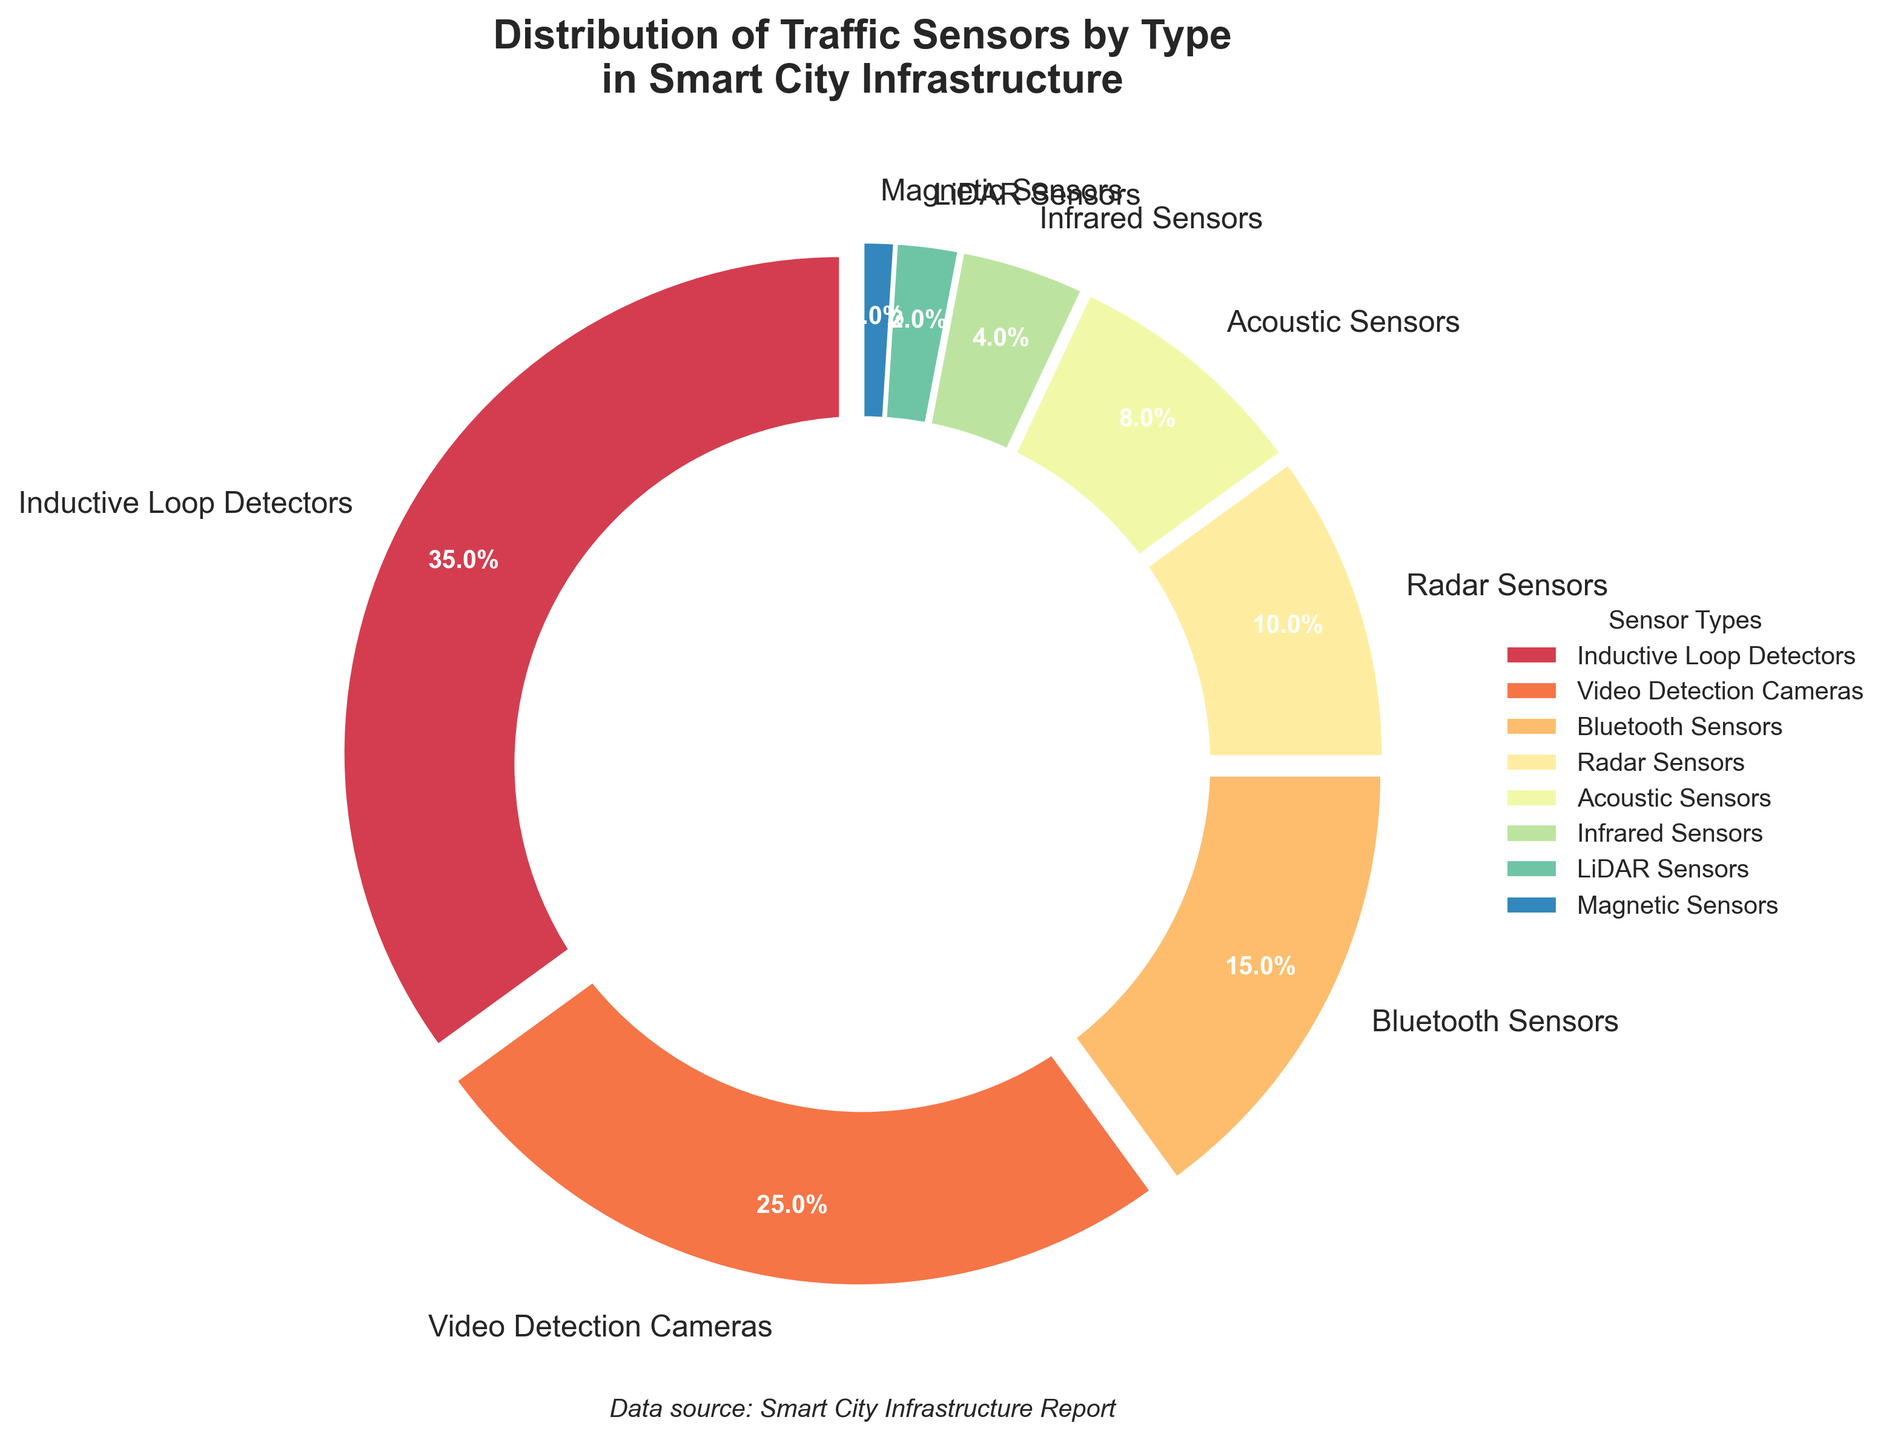What percentage of traffic sensors are Inductive Loop Detectors? The figure shows a pie chart with distinct sections labeled with sensor types and their corresponding percentages. According to the label for Inductive Loop Detectors, the percentage is 35%.
Answer: 35% Which type of traffic sensor has the smallest percentage in the distribution? By observing the pie chart, the section labeled Magnetic Sensors shows the smallest percentage, which is indicated as 1%.
Answer: Magnetic Sensors What is the combined percentage of Radar Sensors and Bluetooth Sensors? The pie chart labels these sensors with their respective percentages: Radar Sensors at 10% and Bluetooth Sensors at 15%. Adding these together gives 10% + 15% = 25%.
Answer: 25% Which sensor type has a higher percentage: Acoustic Sensors or Infrared Sensors? The pie chart shows Acoustic Sensors at 8% and Infrared Sensors at 4%. Comparing these values, Acoustic Sensors have a higher percentage (8% > 4%).
Answer: Acoustic Sensors What is the total percentage of the three most common types of traffic sensors? The three largest sections in the pie chart are Inductive Loop Detectors (35%), Video Detection Cameras (25%), and Bluetooth Sensors (15%). Summing these values gives 35% + 25% + 15% = 75%.
Answer: 75% Are there more Radar Sensors or Video Detection Cameras in the distribution? The pie chart shows that Video Detection Cameras comprise 25% of the sensors, while Radar Sensors make up 10%. Since 25% > 10%, there are more Video Detection Cameras.
Answer: Video Detection Cameras What is the visual difference in the chart between the section representing LiDAR Sensors and Infrared Sensors? LiDAR Sensors and Infrared Sensors are represented by adjacent sections. LiDAR Sensors have a smaller section at 2%, while Infrared Sensors have a slightly larger section at 4%. The Infrared sensors' section is roughly twice the size of the LiDAR sensors' section.
Answer: Infrared Sensors section is larger How much larger is the percentage of Inductive Loop Detectors compared to Acoustic Sensors? The pie chart shows Inductive Loop Detectors at 35% and Acoustic Sensors at 8%. To find the difference, subtract the two percentages: 35% - 8% = 27%.
Answer: 27% 